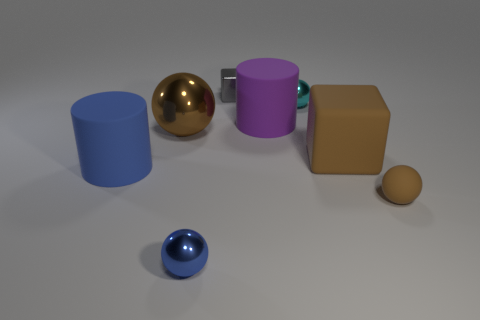Add 2 tiny brown objects. How many objects exist? 10 Subtract all blocks. How many objects are left? 6 Add 7 blue rubber cylinders. How many blue rubber cylinders exist? 8 Subtract 0 blue blocks. How many objects are left? 8 Subtract all gray cubes. Subtract all metallic things. How many objects are left? 3 Add 2 big brown rubber objects. How many big brown rubber objects are left? 3 